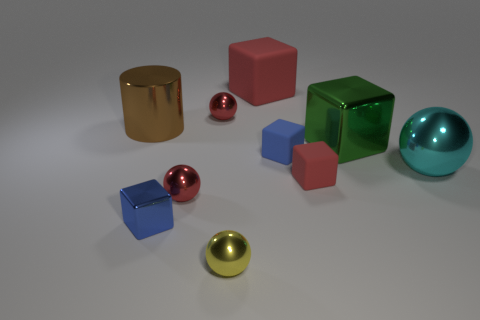What can you tell me about the lighting in this image? The lighting in the image is diffuse, soft, and appears to come from a direction that is not directly visible to us. It casts gentle shadows to the right of the objects, suggesting a light source to the upper left. There are no harsh shadows or stark contrasts, which indicates that the environment in which these objects are placed is evenly lit, likely with a softbox or similar photography lighting equipment to achieve such an effect. 